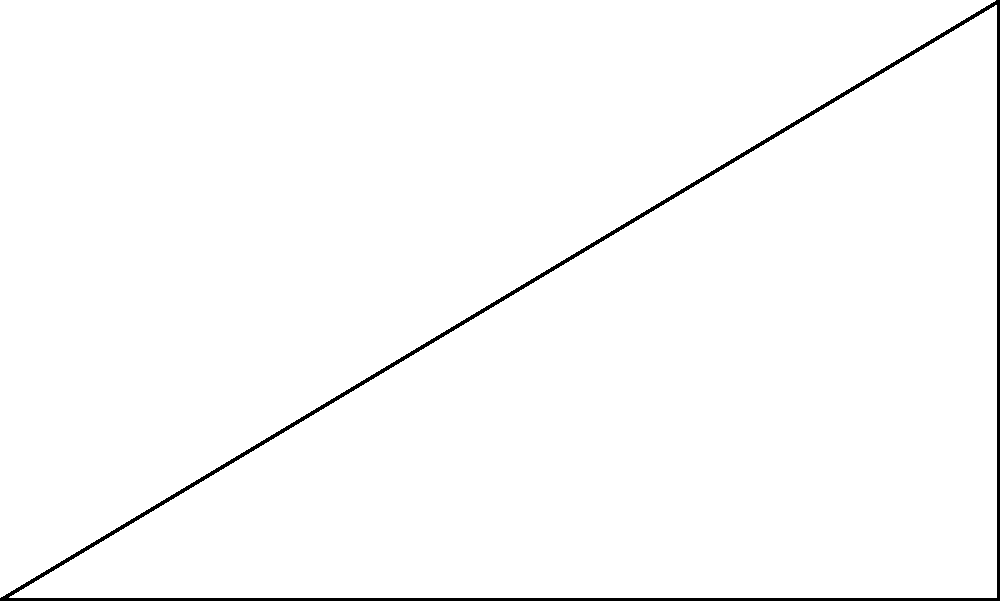In YouTuber animation layouts, the golden ratio is often used to create aesthetically pleasing compositions. Consider the triangle ABC in the diagram, where point D divides AB according to the golden ratio. If AB = 5 units, what is the length of AD to the nearest hundredth? To solve this problem, we'll use the properties of the golden ratio and basic geometry:

1. The golden ratio, denoted by $\phi$ (phi), is approximately equal to 1.618034...

2. In a line segment divided by the golden ratio, the ratio of the longer part to the shorter part is equal to the ratio of the whole segment to the longer part.

3. Let x be the length of AD. Then:
   $\frac{AB}{AD} = \frac{AD}{DB}$

4. We know that AB = 5 units. So we can write:
   $\frac{5}{x} = \frac{x}{5-x}$

5. Cross-multiplying:
   $5(5-x) = x^2$

6. Expanding:
   $25 - 5x = x^2$

7. Rearranging:
   $x^2 + 5x - 25 = 0$

8. This is a quadratic equation. We can solve it using the quadratic formula:
   $x = \frac{-b \pm \sqrt{b^2 - 4ac}}{2a}$

   Where $a=1$, $b=5$, and $c=-25$

9. Plugging in these values:
   $x = \frac{-5 \pm \sqrt{25 + 100}}{2} = \frac{-5 \pm \sqrt{125}}{2}$

10. Simplifying:
    $x = \frac{-5 \pm 5\sqrt{5}}{2}$

11. We take the positive root as we're dealing with length:
    $x = \frac{-5 + 5\sqrt{5}}{2}$

12. Calculating this value:
    $x \approx 3.09$

Therefore, to the nearest hundredth, the length of AD is 3.09 units.
Answer: 3.09 units 